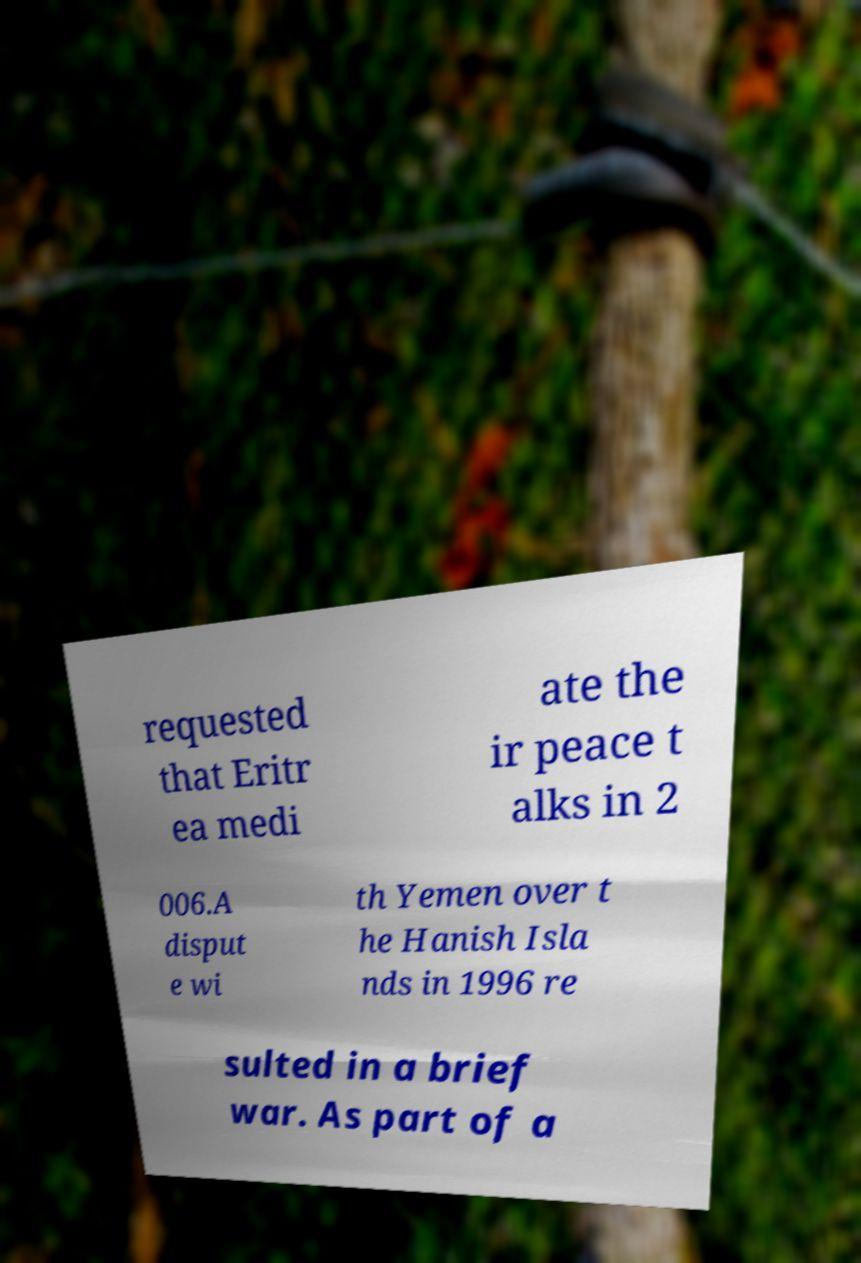Please read and relay the text visible in this image. What does it say? requested that Eritr ea medi ate the ir peace t alks in 2 006.A disput e wi th Yemen over t he Hanish Isla nds in 1996 re sulted in a brief war. As part of a 